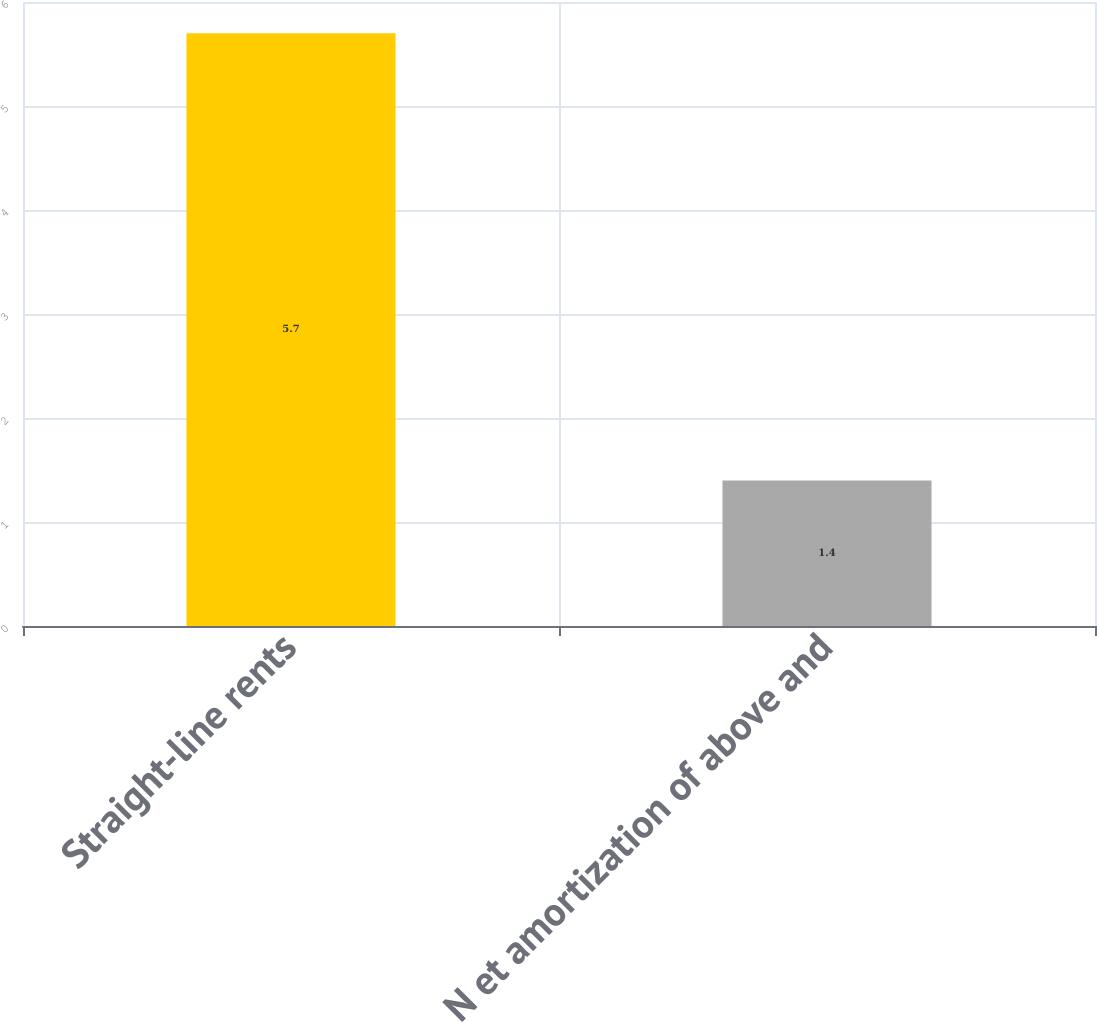Convert chart. <chart><loc_0><loc_0><loc_500><loc_500><bar_chart><fcel>Straight-line rents<fcel>N et amortization of above and<nl><fcel>5.7<fcel>1.4<nl></chart> 